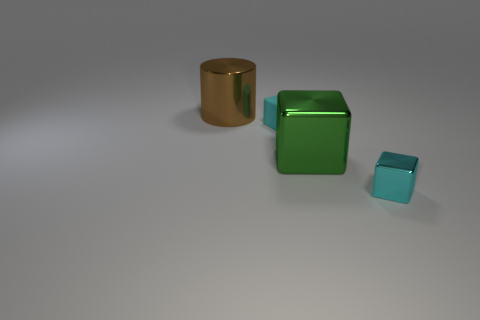Add 2 small gray things. How many objects exist? 6 Subtract all cubes. How many objects are left? 1 Subtract all big shiny things. Subtract all yellow shiny spheres. How many objects are left? 2 Add 2 big metal cubes. How many big metal cubes are left? 3 Add 3 big green spheres. How many big green spheres exist? 3 Subtract 0 gray blocks. How many objects are left? 4 